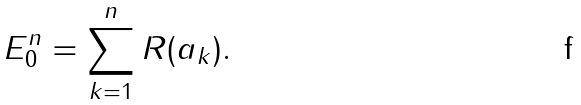<formula> <loc_0><loc_0><loc_500><loc_500>E _ { 0 } ^ { n } = \sum _ { k = 1 } ^ { n } R ( a _ { k } ) .</formula> 